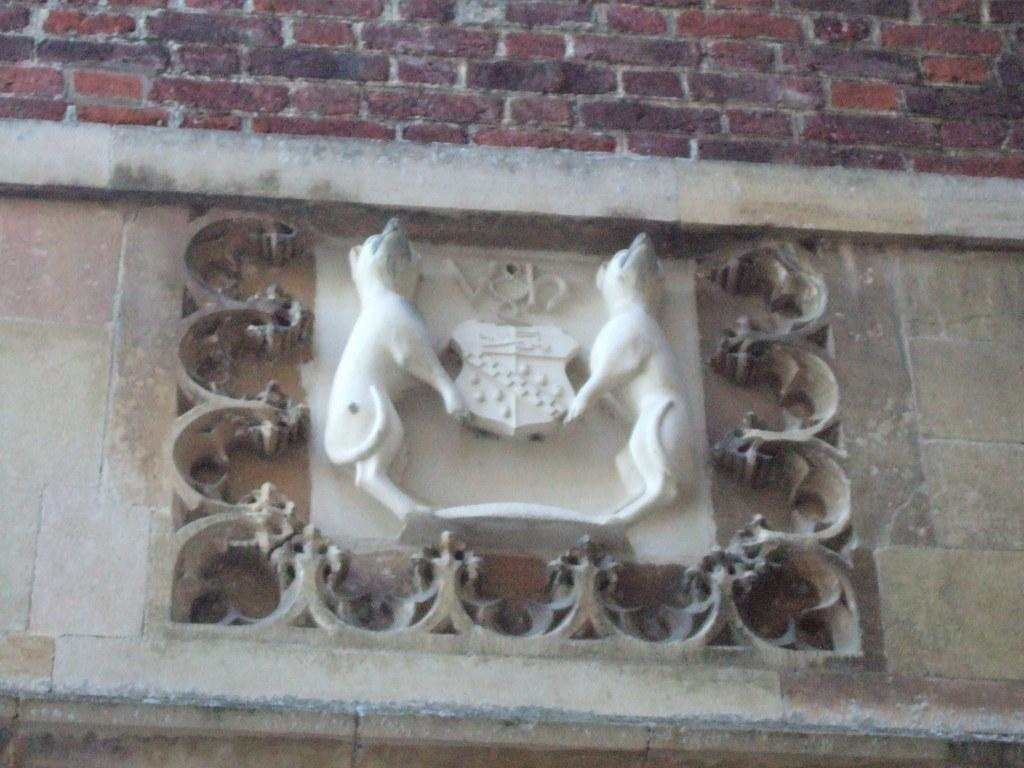What is the main subject of the image? There is a sculpture in the image. What material is the sculpture made of? The sculpture is carved on a stone. How is the sculpture positioned in the image? The sculpture is attached to a wall. What is the wall made of? The wall is made of bricks. What type of pear is depicted in the sculpture? There is no pear present in the image, as the sculpture is carved on a stone and does not depict any fruit. 